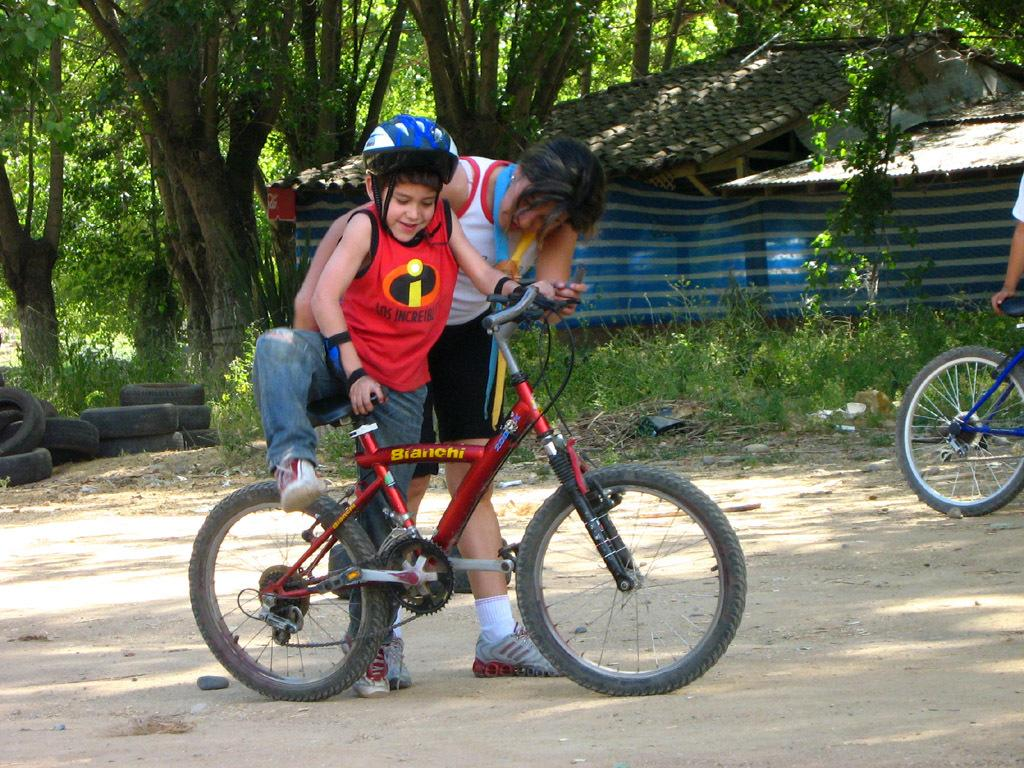Who is the main subject in the image? The main subject in the image is a small boy. What is the boy about to do? The boy is about to sit on a bicycle. Can you describe the lady in the image? There is a lady in the foreground of the image. How many people are present in the image? There are at least three people in the image: the small boy, the lady, and another person. What object is the boy about to use? There is a bicycle in the image that the boy is about to sit on. What can be seen in the background of the image? There is a house and trees in the background of the image. What type of mark can be seen on the bicycle in the image? There is no mention of any mark on the bicycle in the image. 